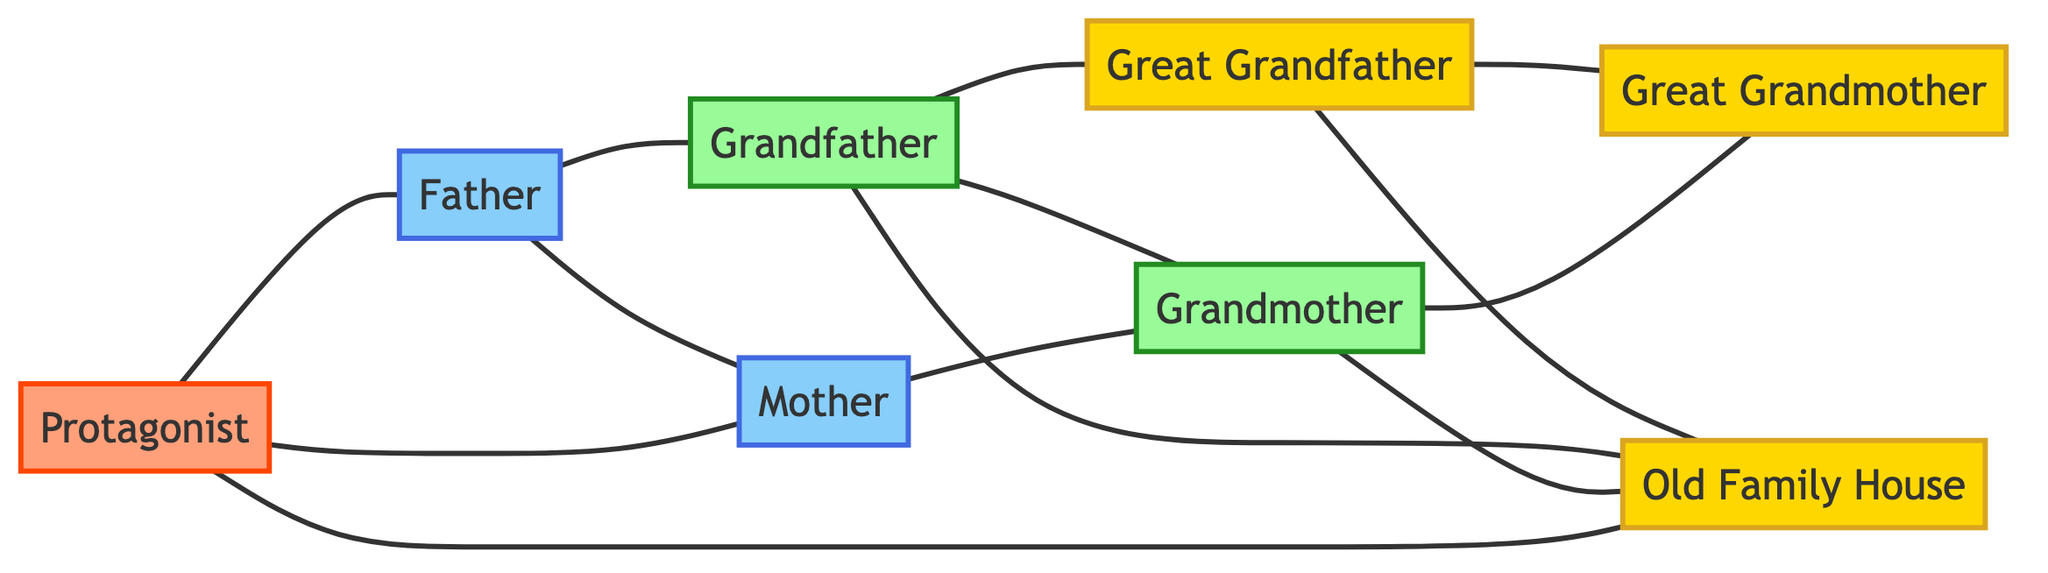What is the total number of nodes in the diagram? The diagram contains 8 nodes: Great Grandfather, Great Grandmother, Grandfather, Grandmother, Father, Mother, Protagonist, and Old Family House. Thus, the total is simply 8.
Answer: 8 Who is connected to the Old Family House? The Old Family House connects to three entities: Great Grandfather, Grandfather, Grandmother, and Protagonist. Notably, since multiple nodes are mentioned, the first answer is sufficient, i.e., Great Grandfather, but we can also denote that there are multiple connections if required.
Answer: Great Grandfather, Grandfather, Grandmother, Protagonist How many edges are there in the diagram? By counting all the listed edges, which show relationships among the nodes, there are a total of 12 edges.
Answer: 12 Which node is connected to both Grandmother and Protagonist? To identify this node, we look for a node that has edges linking it to both Grandmother and Protagonist. The Father is connected to Grandmother, and the Protagonist is linked to Father. Therefore, Father is the only shared connection between them.
Answer: Father How many generations are represented in the diagram? The diagram includes four distinct generations as per the nodes: Great Grandparents (1920s), Grandparents (1940s), Parents (1970s), and Protagonist (2000s). This count indicates the span of four generations.
Answer: 4 What is the relationship between Great Grandfather and Grandfather? Grandfather has a direct edge that connects him to Great Grandfather, indicating a parent-child relationship between them. Therefore, the relationship is that Great Grandfather is the parent of Grandfather.
Answer: Parent-child Which era has the least number of nodes? After analyzing the nodes, we see that the 2000s era only has one node (Protagonist), while others have more. Thus, it has the least count of nodes.
Answer: 2000s What type of relationship exists between Great Grandmother and Grandmother? The three generations of nodes show a direct connection between Great Grandmother (who is a grandparent) and Grandmother (who is her daughter). Hence, the relationship is that Great Grandmother is the mother of Grandmother.
Answer: Mother-daughter 